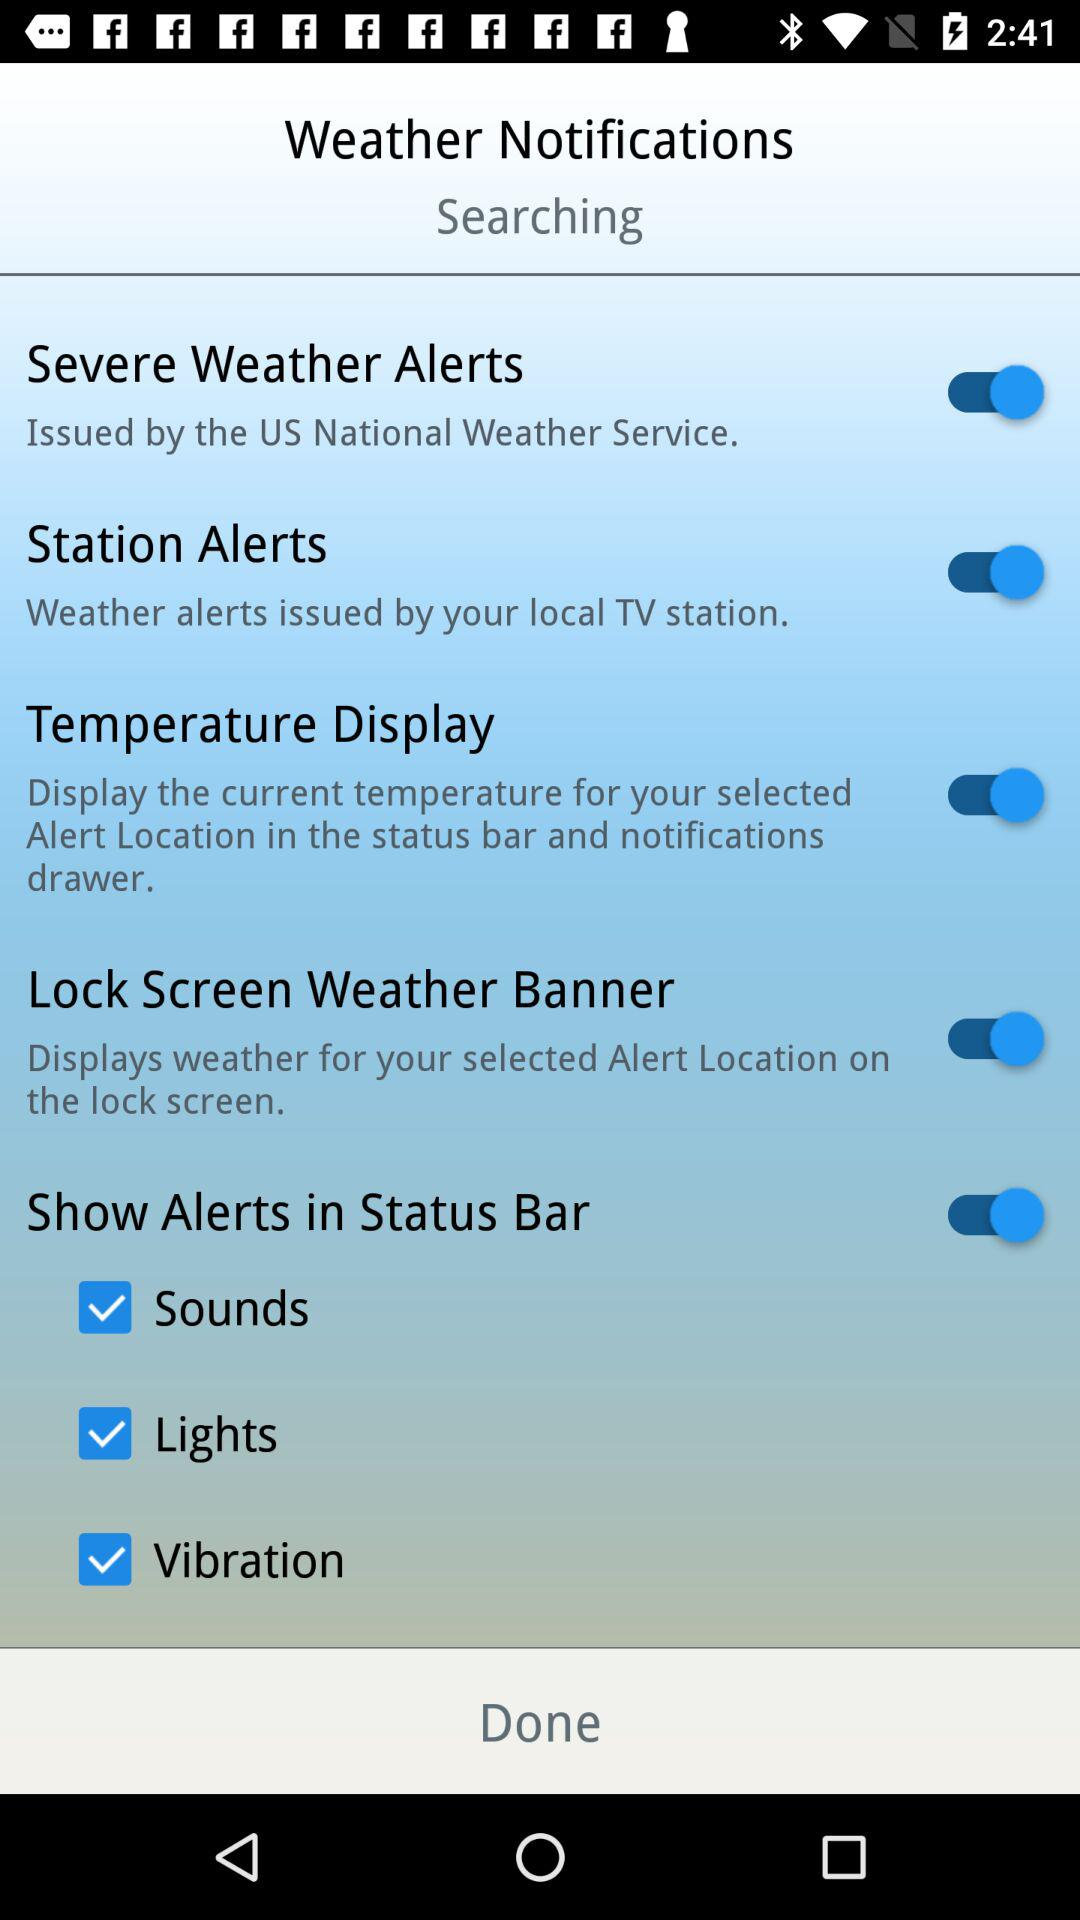How many checkboxes are there for the alert types?
Answer the question using a single word or phrase. 3 